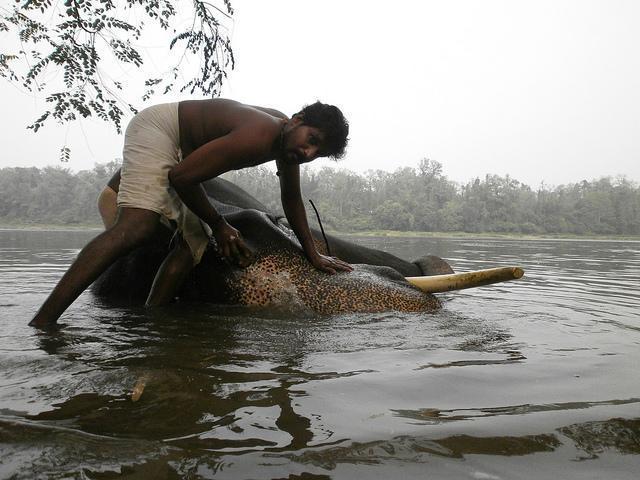How many giraffes are in the cage?
Give a very brief answer. 0. 